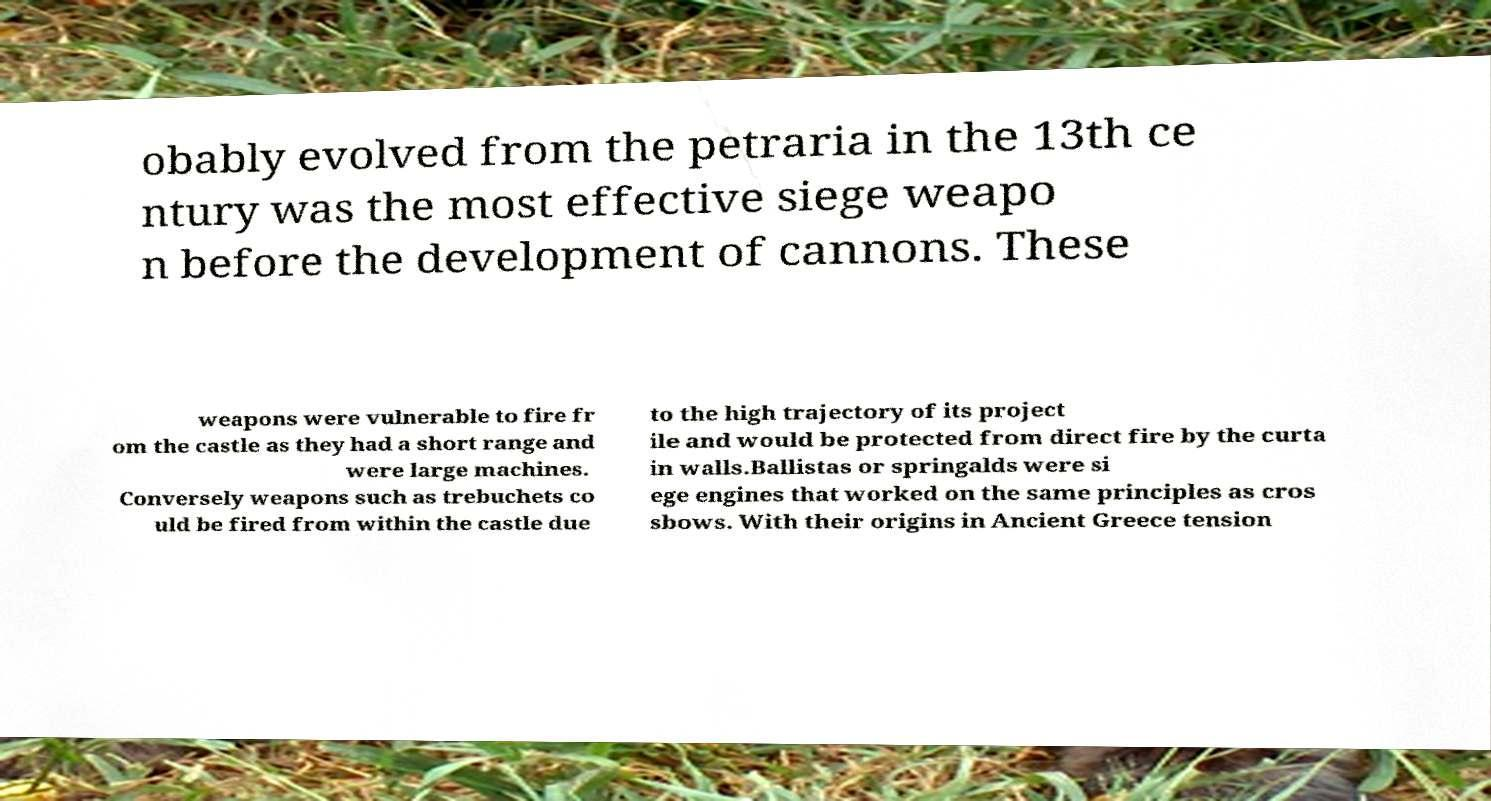Could you extract and type out the text from this image? obably evolved from the petraria in the 13th ce ntury was the most effective siege weapo n before the development of cannons. These weapons were vulnerable to fire fr om the castle as they had a short range and were large machines. Conversely weapons such as trebuchets co uld be fired from within the castle due to the high trajectory of its project ile and would be protected from direct fire by the curta in walls.Ballistas or springalds were si ege engines that worked on the same principles as cros sbows. With their origins in Ancient Greece tension 